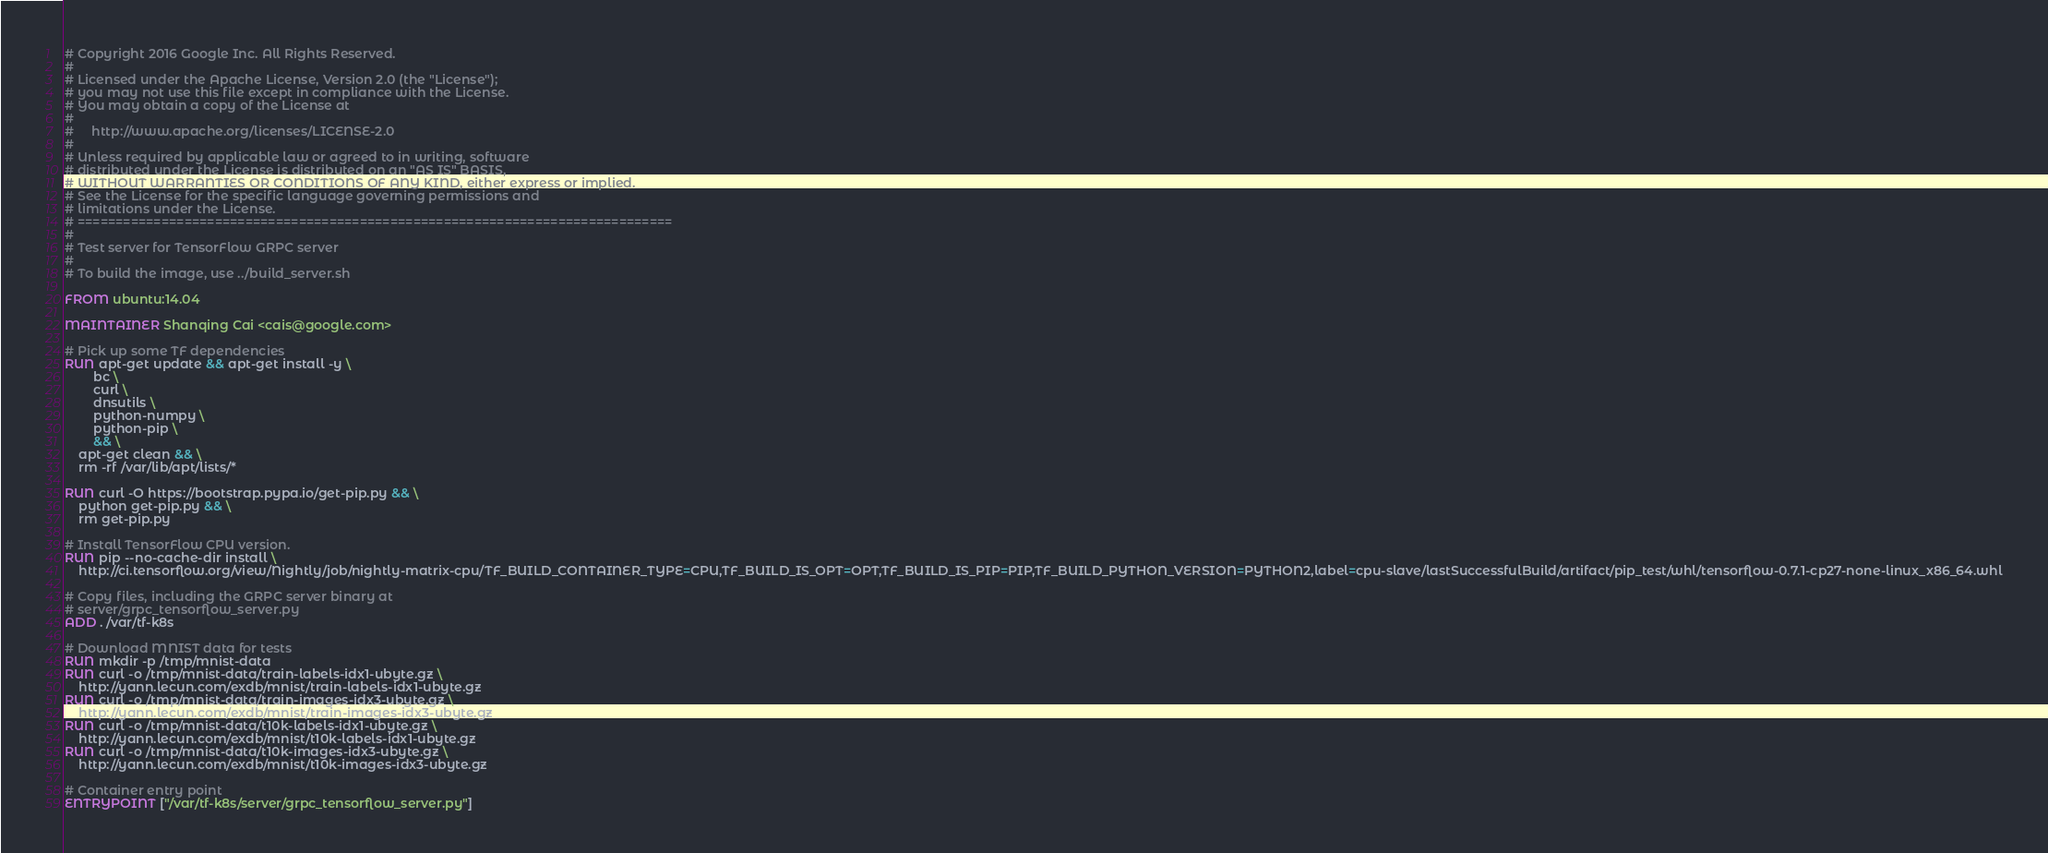<code> <loc_0><loc_0><loc_500><loc_500><_Dockerfile_># Copyright 2016 Google Inc. All Rights Reserved.
#
# Licensed under the Apache License, Version 2.0 (the "License");
# you may not use this file except in compliance with the License.
# You may obtain a copy of the License at
#
#     http://www.apache.org/licenses/LICENSE-2.0
#
# Unless required by applicable law or agreed to in writing, software
# distributed under the License is distributed on an "AS IS" BASIS,
# WITHOUT WARRANTIES OR CONDITIONS OF ANY KIND, either express or implied.
# See the License for the specific language governing permissions and
# limitations under the License.
# ==============================================================================
#
# Test server for TensorFlow GRPC server
#
# To build the image, use ../build_server.sh

FROM ubuntu:14.04

MAINTAINER Shanqing Cai <cais@google.com>

# Pick up some TF dependencies
RUN apt-get update && apt-get install -y \
        bc \
        curl \
        dnsutils \
        python-numpy \
        python-pip \
        && \
    apt-get clean && \
    rm -rf /var/lib/apt/lists/*

RUN curl -O https://bootstrap.pypa.io/get-pip.py && \
    python get-pip.py && \
    rm get-pip.py

# Install TensorFlow CPU version.
RUN pip --no-cache-dir install \
    http://ci.tensorflow.org/view/Nightly/job/nightly-matrix-cpu/TF_BUILD_CONTAINER_TYPE=CPU,TF_BUILD_IS_OPT=OPT,TF_BUILD_IS_PIP=PIP,TF_BUILD_PYTHON_VERSION=PYTHON2,label=cpu-slave/lastSuccessfulBuild/artifact/pip_test/whl/tensorflow-0.7.1-cp27-none-linux_x86_64.whl

# Copy files, including the GRPC server binary at
# server/grpc_tensorflow_server.py
ADD . /var/tf-k8s

# Download MNIST data for tests
RUN mkdir -p /tmp/mnist-data
RUN curl -o /tmp/mnist-data/train-labels-idx1-ubyte.gz \
    http://yann.lecun.com/exdb/mnist/train-labels-idx1-ubyte.gz
RUN curl -o /tmp/mnist-data/train-images-idx3-ubyte.gz \
    http://yann.lecun.com/exdb/mnist/train-images-idx3-ubyte.gz
RUN curl -o /tmp/mnist-data/t10k-labels-idx1-ubyte.gz \
    http://yann.lecun.com/exdb/mnist/t10k-labels-idx1-ubyte.gz
RUN curl -o /tmp/mnist-data/t10k-images-idx3-ubyte.gz \
    http://yann.lecun.com/exdb/mnist/t10k-images-idx3-ubyte.gz

# Container entry point
ENTRYPOINT ["/var/tf-k8s/server/grpc_tensorflow_server.py"]
</code> 